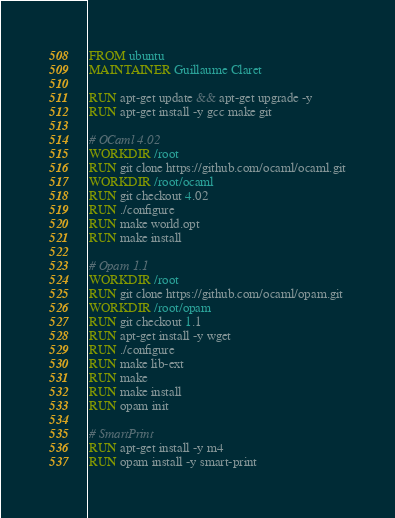Convert code to text. <code><loc_0><loc_0><loc_500><loc_500><_Dockerfile_>FROM ubuntu
MAINTAINER Guillaume Claret

RUN apt-get update && apt-get upgrade -y
RUN apt-get install -y gcc make git

# OCaml 4.02
WORKDIR /root
RUN git clone https://github.com/ocaml/ocaml.git
WORKDIR /root/ocaml
RUN git checkout 4.02
RUN ./configure
RUN make world.opt
RUN make install

# Opam 1.1
WORKDIR /root
RUN git clone https://github.com/ocaml/opam.git
WORKDIR /root/opam
RUN git checkout 1.1
RUN apt-get install -y wget
RUN ./configure
RUN make lib-ext
RUN make
RUN make install
RUN opam init

# SmartPrint
RUN apt-get install -y m4
RUN opam install -y smart-print</code> 